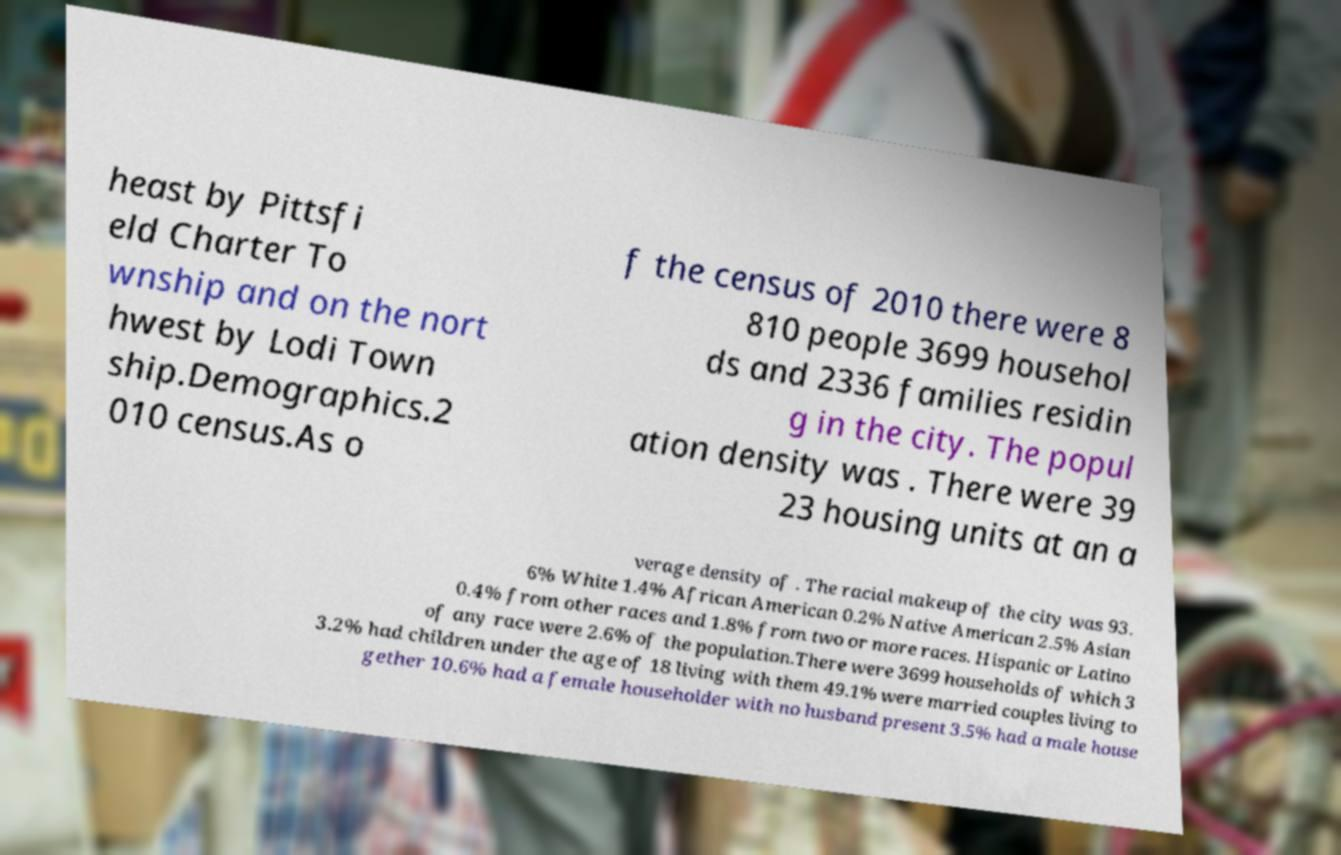I need the written content from this picture converted into text. Can you do that? heast by Pittsfi eld Charter To wnship and on the nort hwest by Lodi Town ship.Demographics.2 010 census.As o f the census of 2010 there were 8 810 people 3699 househol ds and 2336 families residin g in the city. The popul ation density was . There were 39 23 housing units at an a verage density of . The racial makeup of the city was 93. 6% White 1.4% African American 0.2% Native American 2.5% Asian 0.4% from other races and 1.8% from two or more races. Hispanic or Latino of any race were 2.6% of the population.There were 3699 households of which 3 3.2% had children under the age of 18 living with them 49.1% were married couples living to gether 10.6% had a female householder with no husband present 3.5% had a male house 